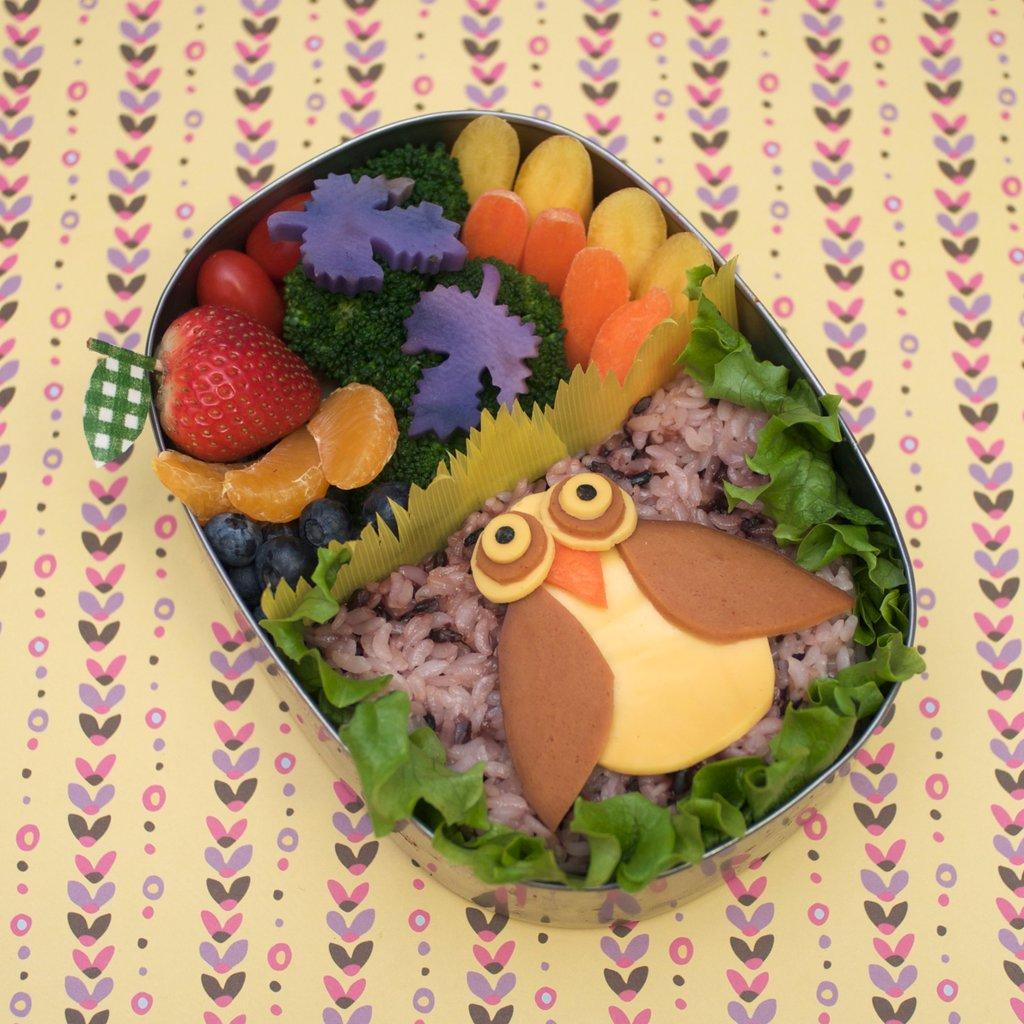What is in the bowl that is visible in the image? There is food in a bowl in the image. What can be said about the surface the bowl is placed on? The surface the bowl is on has yellow and pink colors. What type of pest can be seen crawling on the food in the image? There is no pest visible in the image; the food appears to be undisturbed. 